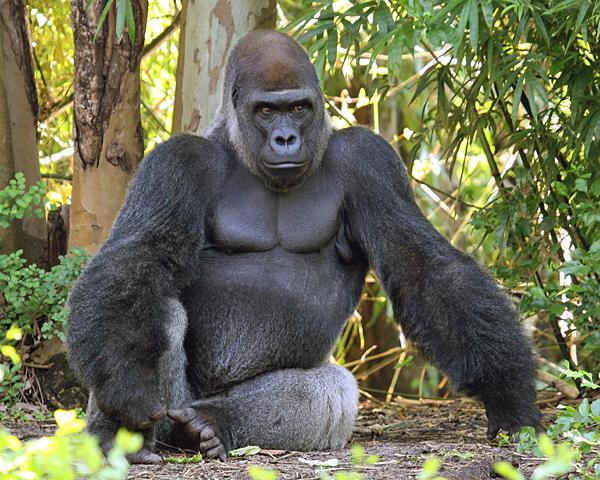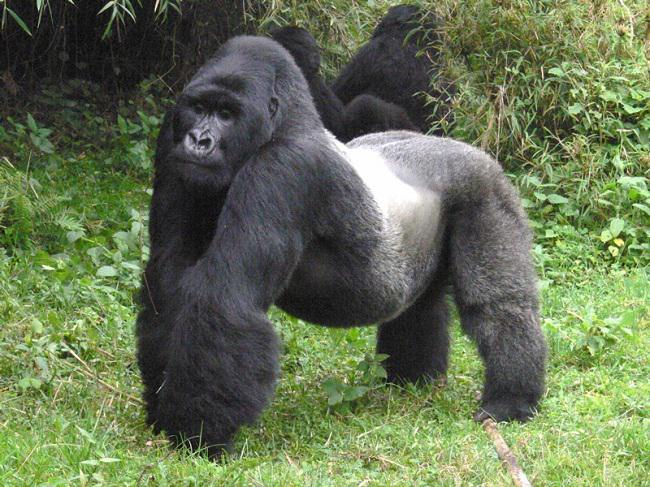The first image is the image on the left, the second image is the image on the right. Evaluate the accuracy of this statement regarding the images: "A baby gorilla is being carried by its mother.". Is it true? Answer yes or no. No. The first image is the image on the left, the second image is the image on the right. For the images displayed, is the sentence "An image includes a baby gorilla with at least one adult gorilla." factually correct? Answer yes or no. No. 